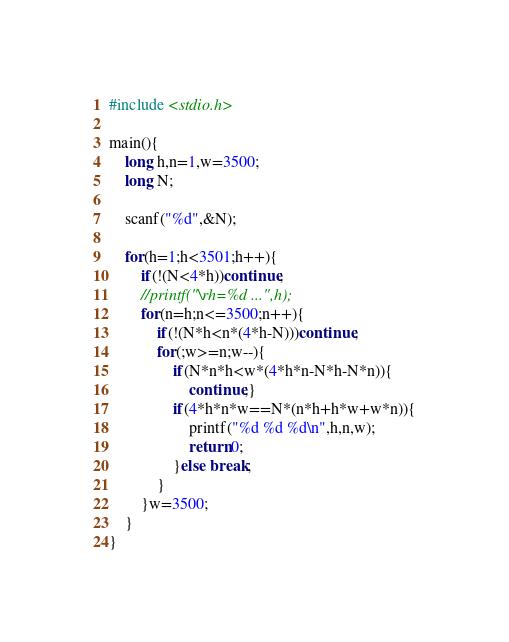<code> <loc_0><loc_0><loc_500><loc_500><_C_>#include <stdio.h>

main(){
    long h,n=1,w=3500;
    long N;

    scanf("%d",&N);

    for(h=1;h<3501;h++){
        if(!(N<4*h))continue;
        //printf("\rh=%d ...",h);
        for(n=h;n<=3500;n++){
            if(!(N*h<n*(4*h-N)))continue;
            for(;w>=n;w--){
                if(N*n*h<w*(4*h*n-N*h-N*n)){
                    continue;}
                if(4*h*n*w==N*(n*h+h*w+w*n)){
                    printf("%d %d %d\n",h,n,w);
                    return 0;
                }else break;
            }
        }w=3500;
    }
}
</code> 